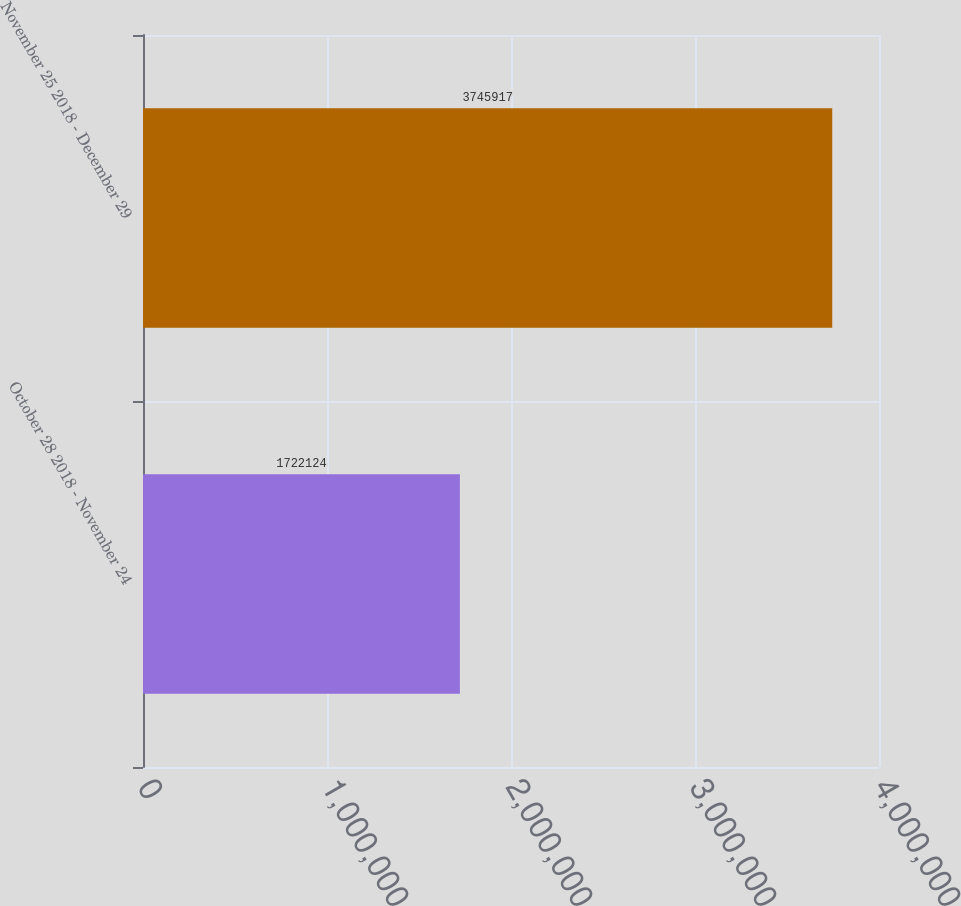Convert chart. <chart><loc_0><loc_0><loc_500><loc_500><bar_chart><fcel>October 28 2018 - November 24<fcel>November 25 2018 - December 29<nl><fcel>1.72212e+06<fcel>3.74592e+06<nl></chart> 